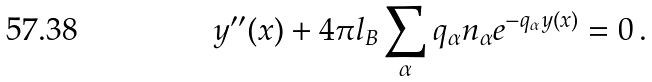<formula> <loc_0><loc_0><loc_500><loc_500>y ^ { \prime \prime } ( x ) + 4 \pi l _ { B } \sum _ { \alpha } q _ { \alpha } n _ { \alpha } e ^ { - q _ { \alpha } y ( x ) } = 0 \, .</formula> 